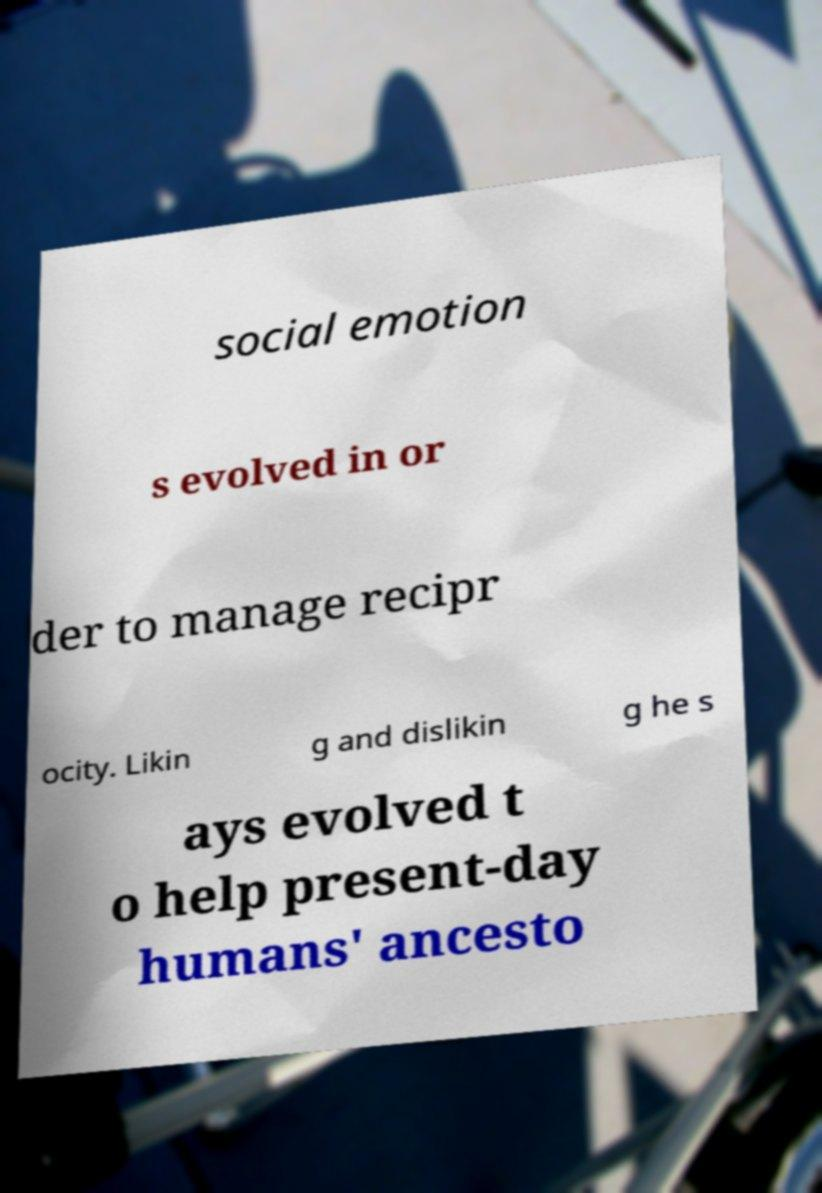Can you accurately transcribe the text from the provided image for me? social emotion s evolved in or der to manage recipr ocity. Likin g and dislikin g he s ays evolved t o help present-day humans' ancesto 